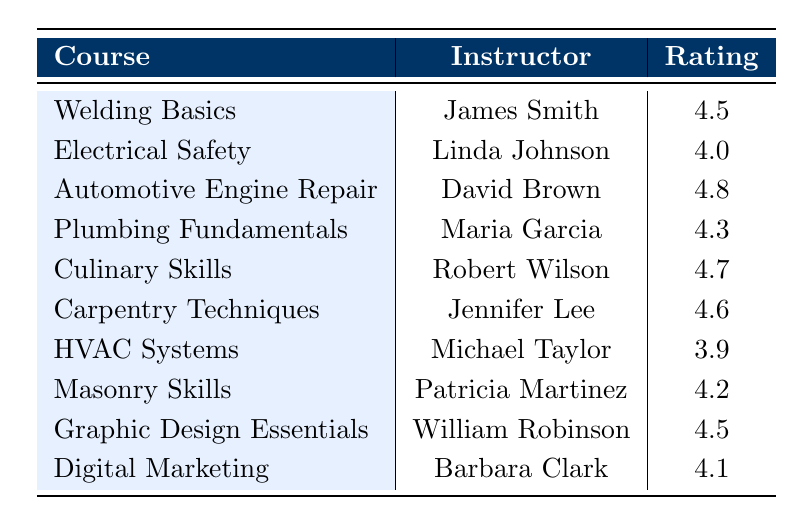What is the highest rating among the courses? From the table, I can check the ratings listed for each course. The highest rating noted is 4.8 for the "Automotive Engine Repair" course taught by David Brown.
Answer: 4.8 Who is the instructor for the "Culinary Skills" course? The table directly states that the instructor for the "Culinary Skills" course is Robert Wilson.
Answer: Robert Wilson Is the rating for "HVAC Systems" higher than 4.0? The rating for "HVAC Systems", as per the table, is 3.9, which is not higher than 4.0. Hence, the answer is no.
Answer: No What is the average rating of all courses? To find the average rating, I add all the ratings: 4.5 + 4.0 + 4.8 + 4.3 + 4.7 + 4.6 + 3.9 + 4.2 + 4.5 + 4.1 = 46.6. Dividing this sum by the number of courses, which is 10, gives me an average of 46.6/10 = 4.66.
Answer: 4.66 Which course has a rating lower than "Plumbing Fundamentals"? The rating for "Plumbing Fundamentals" is 4.3. Looking at the table, the course "HVAC Systems" has a rating of 3.9, which is lower than 4.3. Therefore, that is the only course listed.
Answer: HVAC Systems 